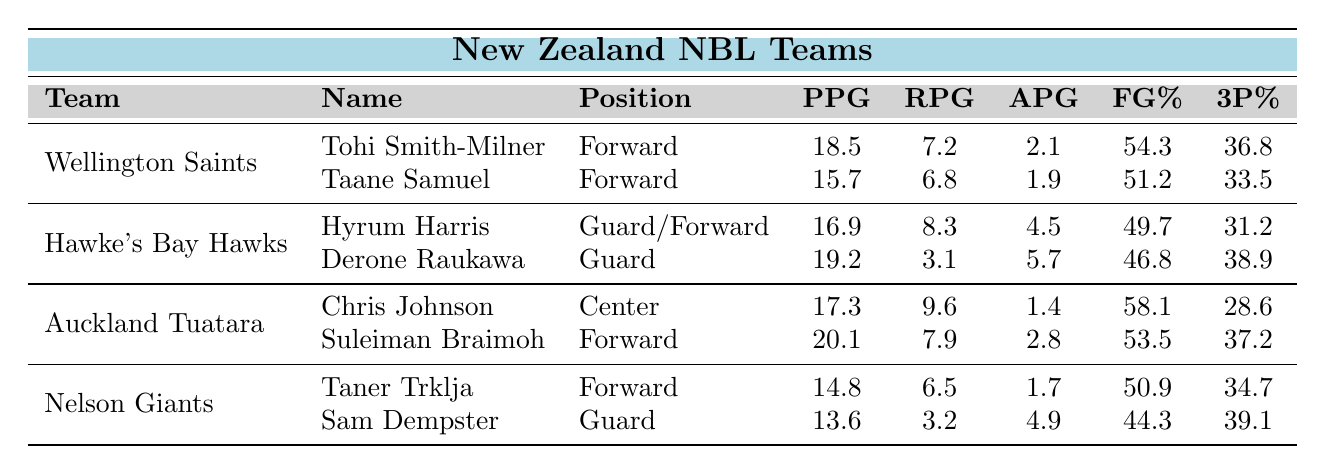What is the highest points per game (PPG) scored by a player in the Wellington Saints? The player with the highest PPG for Wellington Saints is Tohi Smith-Milner, who scored 18.5 PPG.
Answer: 18.5 Which team has the player with the highest rebounds per game (RPG)? Suleiman Braimoh of Auckland Tuatara has the highest RPG at 7.9.
Answer: Auckland Tuatara What is the average assists per game (APG) for the players on the Hawke's Bay Hawks? The total APG for Hyrum Harris (4.5) and Derone Raukawa (5.7) is 10.2, dividing by 2 gives an average of 5.1.
Answer: 5.1 Do any players have a field goal percentage (FG%) over 58%? Yes, Chris Johnson from Auckland Tuatara has a FG% of 58.1.
Answer: Yes How many players from Nelson Giants scored more than 14 PPG? Only Taner Trklja scored 14.8 PPG which is more than 14, while Sam Dempster scored 13.6 PPG, hence only 1 player meets the criteria.
Answer: 1 What is the total PPG for the players from Auckland Tuatara? Chris Johnson (17.3) + Suleiman Braimoh (20.1) = 37.4.
Answer: 37.4 Which player has the highest 3-point percentage (3P%) across all teams? Derone Raukawa from Hawke's Bay Hawks has the highest 3P% at 38.9%.
Answer: 38.9 What is the difference in PPG between the highest scorer from Auckland Tuatara and Wellington Saints? Suleiman Braimoh (20.1) - Tohi Smith-Milner (18.5) = 1.6; so the difference is 1.6 PPG.
Answer: 1.6 Are there any players with the same position in different teams? Yes, both Tohi Smith-Milner and Taane Samuel from Wellington Saints play as forwards.
Answer: Yes What is the total number of rebounds per game (RPG) for all players from the Nelson Giants? Taner Trklja (6.5) + Sam Dempster (3.2) = 9.7 RPG total.
Answer: 9.7 